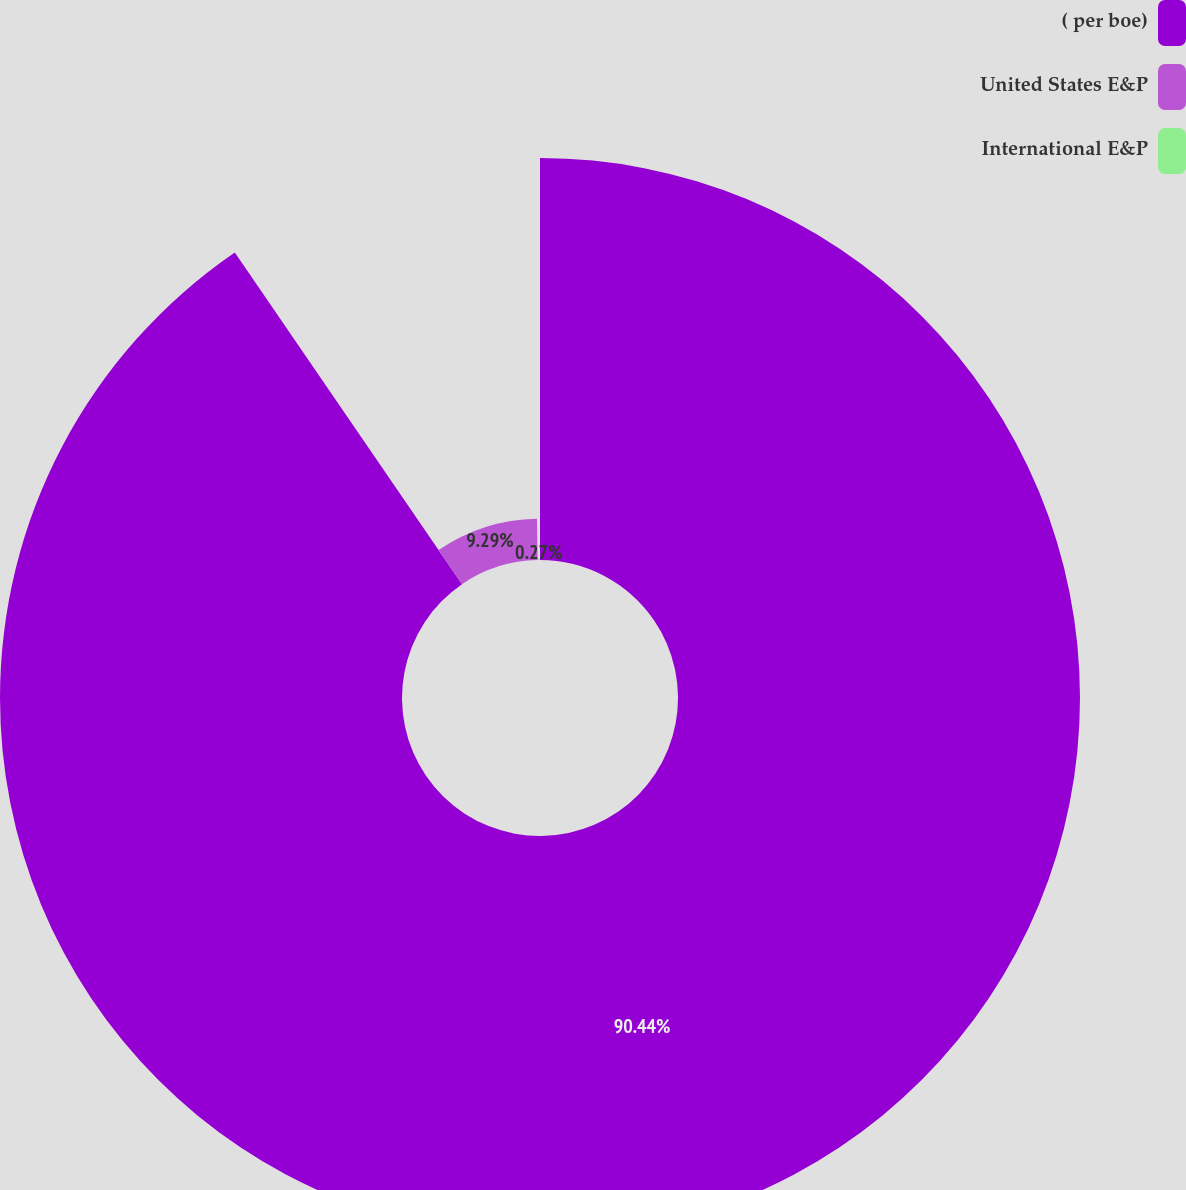Convert chart. <chart><loc_0><loc_0><loc_500><loc_500><pie_chart><fcel>( per boe)<fcel>United States E&P<fcel>International E&P<nl><fcel>90.44%<fcel>9.29%<fcel>0.27%<nl></chart> 